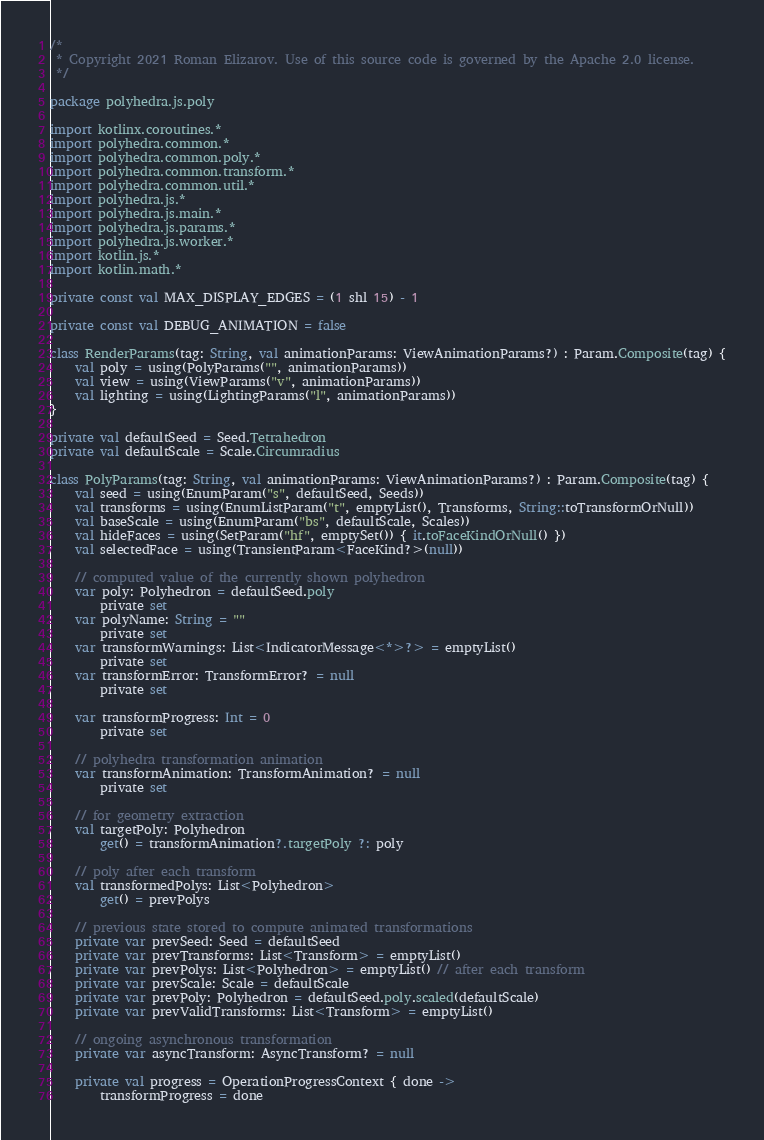Convert code to text. <code><loc_0><loc_0><loc_500><loc_500><_Kotlin_>/*
 * Copyright 2021 Roman Elizarov. Use of this source code is governed by the Apache 2.0 license.
 */

package polyhedra.js.poly

import kotlinx.coroutines.*
import polyhedra.common.*
import polyhedra.common.poly.*
import polyhedra.common.transform.*
import polyhedra.common.util.*
import polyhedra.js.*
import polyhedra.js.main.*
import polyhedra.js.params.*
import polyhedra.js.worker.*
import kotlin.js.*
import kotlin.math.*

private const val MAX_DISPLAY_EDGES = (1 shl 15) - 1

private const val DEBUG_ANIMATION = false

class RenderParams(tag: String, val animationParams: ViewAnimationParams?) : Param.Composite(tag) {
    val poly = using(PolyParams("", animationParams))
    val view = using(ViewParams("v", animationParams))
    val lighting = using(LightingParams("l", animationParams))
}

private val defaultSeed = Seed.Tetrahedron
private val defaultScale = Scale.Circumradius

class PolyParams(tag: String, val animationParams: ViewAnimationParams?) : Param.Composite(tag) {
    val seed = using(EnumParam("s", defaultSeed, Seeds))
    val transforms = using(EnumListParam("t", emptyList(), Transforms, String::toTransformOrNull))
    val baseScale = using(EnumParam("bs", defaultScale, Scales))
    val hideFaces = using(SetParam("hf", emptySet()) { it.toFaceKindOrNull() })
    val selectedFace = using(TransientParam<FaceKind?>(null))

    // computed value of the currently shown polyhedron
    var poly: Polyhedron = defaultSeed.poly
        private set
    var polyName: String = ""
        private set
    var transformWarnings: List<IndicatorMessage<*>?> = emptyList()
        private set
    var transformError: TransformError? = null
        private set

    var transformProgress: Int = 0
        private set

    // polyhedra transformation animation
    var transformAnimation: TransformAnimation? = null
        private set

    // for geometry extraction
    val targetPoly: Polyhedron
        get() = transformAnimation?.targetPoly ?: poly

    // poly after each transform
    val transformedPolys: List<Polyhedron>
        get() = prevPolys

    // previous state stored to compute animated transformations
    private var prevSeed: Seed = defaultSeed
    private var prevTransforms: List<Transform> = emptyList()
    private var prevPolys: List<Polyhedron> = emptyList() // after each transform
    private var prevScale: Scale = defaultScale
    private var prevPoly: Polyhedron = defaultSeed.poly.scaled(defaultScale)
    private var prevValidTransforms: List<Transform> = emptyList()

    // ongoing asynchronous transformation
    private var asyncTransform: AsyncTransform? = null

    private val progress = OperationProgressContext { done ->
        transformProgress = done</code> 